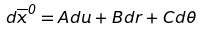Convert formula to latex. <formula><loc_0><loc_0><loc_500><loc_500>d \overline { x } ^ { 0 } = A d u + B d r + C d \theta</formula> 